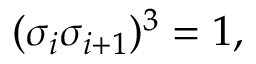<formula> <loc_0><loc_0><loc_500><loc_500>( \sigma _ { i } \sigma _ { i + 1 } ) ^ { 3 } = 1 ,</formula> 